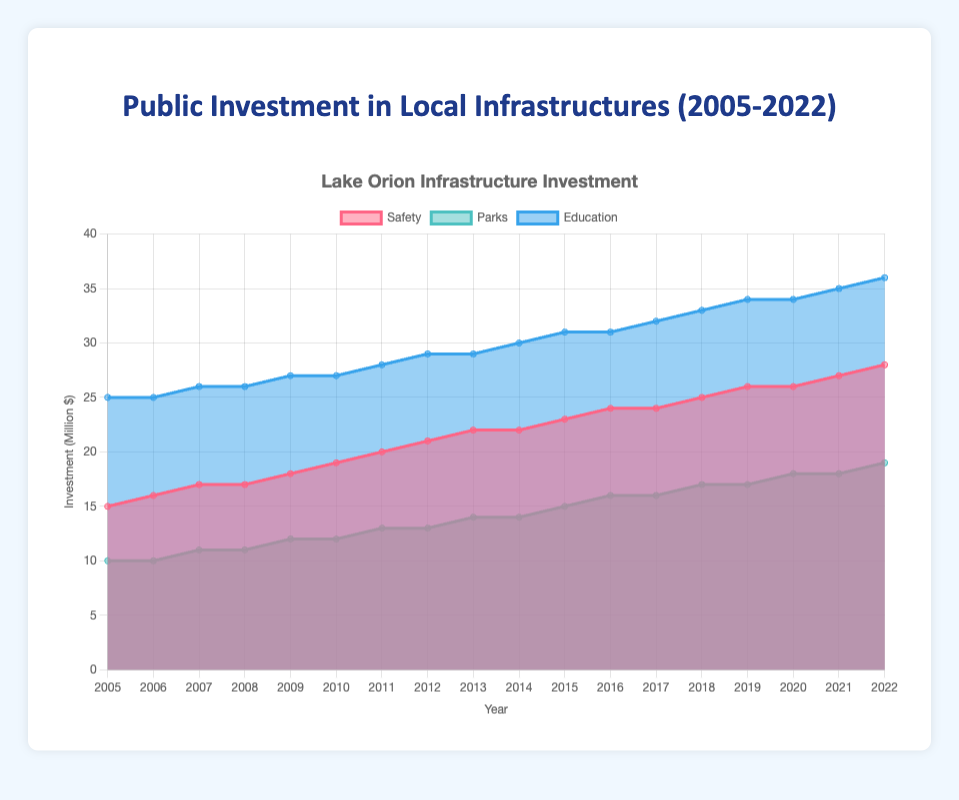What's the overall trend in public investment from 2005 to 2022? The figure shows an increasing trend in total public investment over time. Starting from 50 million in 2005, it gradually rises to 83 million in 2022. The investment amount increases consistently each year.
Answer: Increasing How does the investment in parks change from 2005 to 2022? The investment in parks remains static at 10 million dollars in 2005 and 2006, then starts to increase slowly each year, reaching 19 million dollars in 2022.
Answer: Gradually increases Which infrastructure category has the highest investment in 2022? By looking at the 2022 data points, the investment in education is at 36 million dollars, which is higher than parks (19 million) and safety (28 million).
Answer: Education By how much did the total investment grow from 2010 to 2022? The total investment in 2010 was 58 million dollars, which increased to 83 million dollars in 2022. The growth is calculated as 83 - 58 = 25 million dollars.
Answer: 25 million dollars Compare the growth trends between safety and education investments from 2005 to 2022. The safety investment starts at 15 million dollars in 2005 and reaches 28 million dollars in 2022, while the education investment starts at 25 million dollars in 2005 and reaches 36 million dollars in 2022. Both categories show a steady increase, but education remains consistently higher.
Answer: Both increase, education remains higher What is the proportion of the total investment allocated to parks in 2022? In 2022, the investment in parks is 19 million dollars out of a total investment of 83 million dollars. The proportion is (19 / 83) * 100 ≈ 22.89%.
Answer: Approximately 22.89% Is there any year where the investment in education remained constant from the previous year? From the data plot, the investment in education remained constant in 2006 and 2007 (both 25 million), and between 2008 and 2009 (both 26 million).
Answer: 2006 and 2008 How significant is the increase in investment in safety between 2011 and 2021? The investment in safety was 20 million dollars in 2011 and increased to 27 million dollars in 2021. The increase is 27 - 20 = 7 million dollars.
Answer: 7 million dollars What unique insight can you gather about the investment in parks relative to the total investment over the years? When considering the trend for parks, the investment grows but at a slower pace compared to the total investment. While the total investment increases significantly, parks' investment sees a moderate rise, suggesting a relatively smaller allocation proportion over time.
Answer: Moderate rise compare to bigger total investment growth 